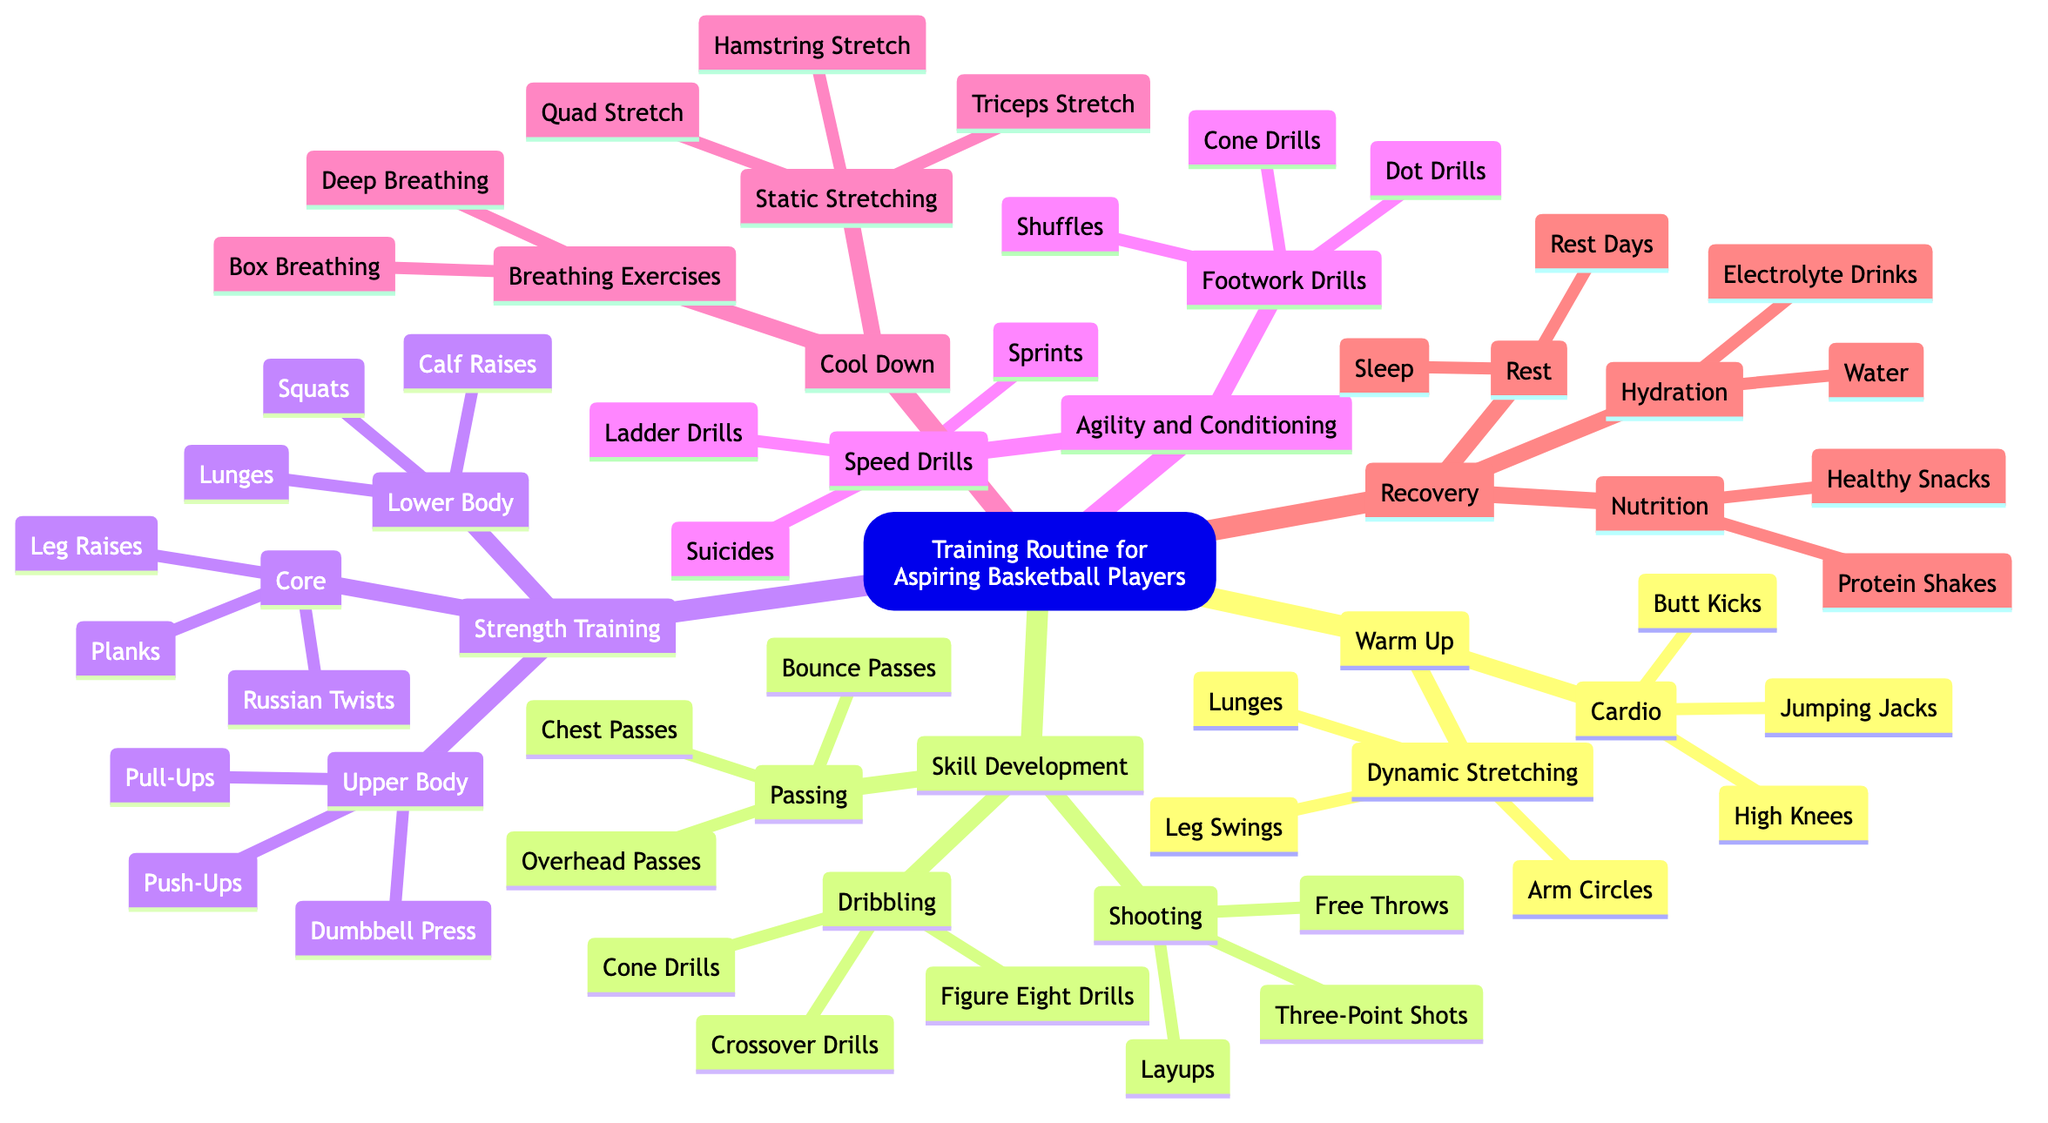What are three activities listed under Cardio? Cardio has three activities listed as Jumping Jacks, High Knees, and Butt Kicks. These are all specific exercises aimed at warming up.
Answer: Jumping Jacks, High Knees, Butt Kicks How many main categories are there in the training routine? The main categories in the training routine are Warm Up, Skill Development, Strength Training, Agility and Conditioning, Cool Down, and Recovery, totaling six categories.
Answer: 6 Which skill development activity has the drills for shooting? The activities for shooting under skill development are Free Throws, Three-Point Shots, and Layups. This is directly categorized as Shooting in the skill development section.
Answer: Shooting What type of stretch is included in the Cool Down section? The cool down section contains Static Stretching and Breathing Exercises. Static Stretching involves Hamstring Stretch, Quad Stretch, and Triceps Stretch.
Answer: Static Stretching What is one strength training exercise listed for the upper body? Under Strength Training, for the Upper Body section, one exercise listed is Push-Ups. This is categorized specifically under upper body exercises.
Answer: Push-Ups How do speed drills differ from agility drills? Speed Drills include Suicides, Ladder Drills, and Sprints, focusing on running speed, while Footwork Drills under Agility and Conditioning include Cone Drills, Dot Drills, and Shuffles, focusing on improving movement and foot speed.
Answer: Speed drills focus on running; agility drills focus on footwork What types of drinks are mentioned for hydration under Recovery? In the Recovery section, the drinks mentioned for hydration include Water and Electrolyte Drinks. These are important to stay hydrated after workouts.
Answer: Water, Electrolyte Drinks What is one breathing exercise recommended in the Cool Down section? In the Cool Down section, one breathing exercise recommended is Deep Breathing. This helps in relaxation after training sessions.
Answer: Deep Breathing 